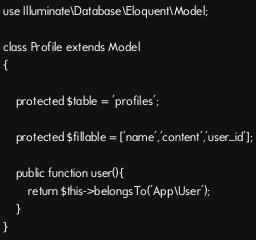Convert code to text. <code><loc_0><loc_0><loc_500><loc_500><_PHP_>
use Illuminate\Database\Eloquent\Model;

class Profile extends Model
{
    
    protected $table = 'profiles';
     
    protected $fillable = ['name','content','user_id'];
    
    public function user(){
        return $this->belongsTo('App\User');
    }
}
</code> 